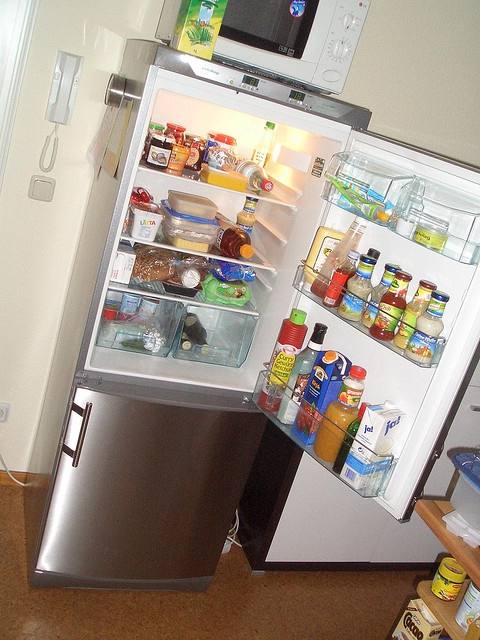Describe the objects in this image and their specific colors. I can see refrigerator in white, lightgray, darkgray, gray, and maroon tones, microwave in white, lightgray, gray, black, and darkgray tones, bottle in white, olive, lightgray, brown, and orange tones, bottle in white, brown, gray, and olive tones, and bottle in white, lightgray, darkgray, and tan tones in this image. 